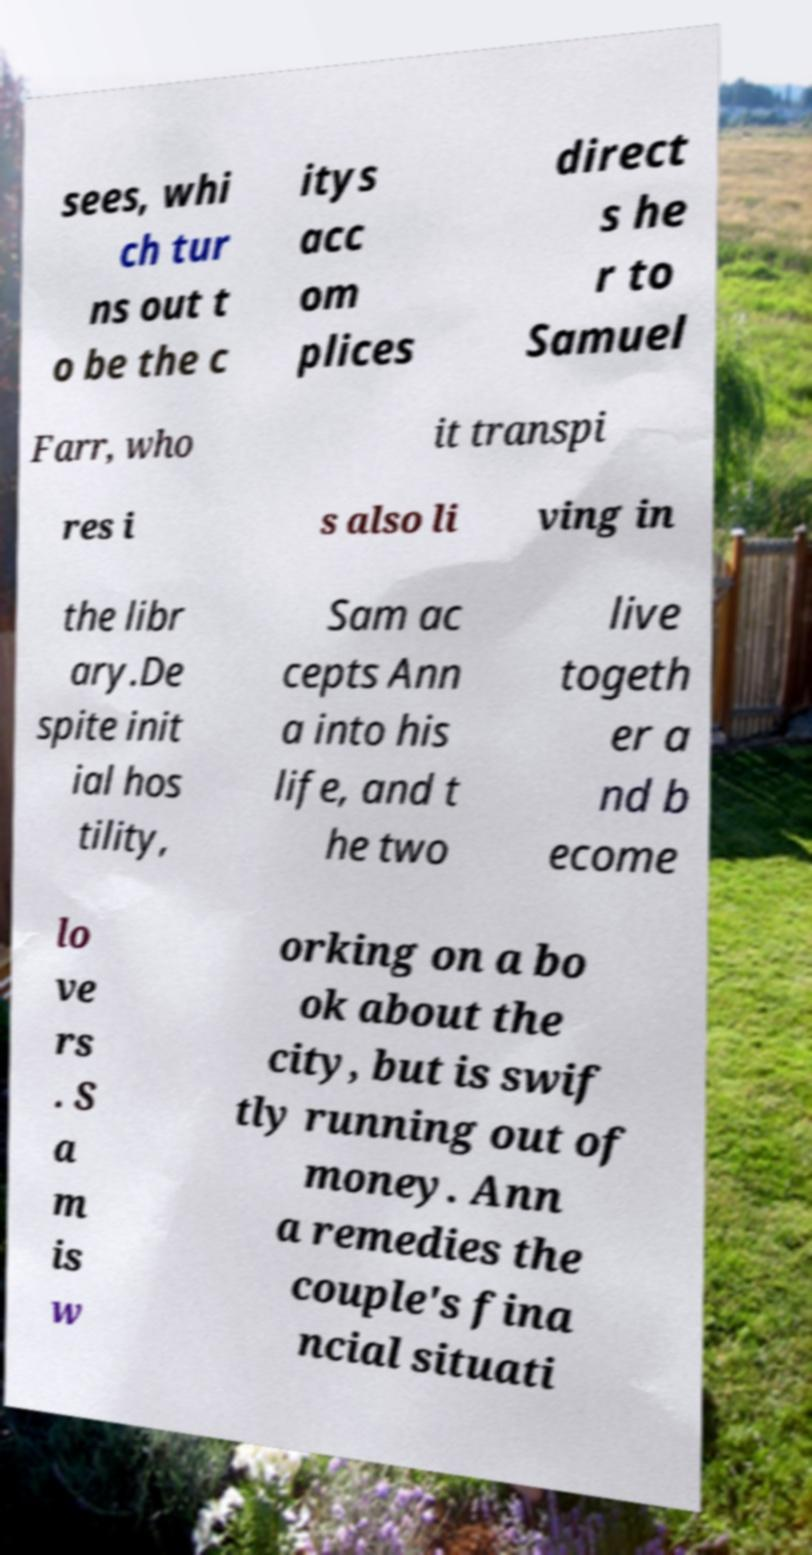Can you accurately transcribe the text from the provided image for me? sees, whi ch tur ns out t o be the c itys acc om plices direct s he r to Samuel Farr, who it transpi res i s also li ving in the libr ary.De spite init ial hos tility, Sam ac cepts Ann a into his life, and t he two live togeth er a nd b ecome lo ve rs . S a m is w orking on a bo ok about the city, but is swif tly running out of money. Ann a remedies the couple's fina ncial situati 